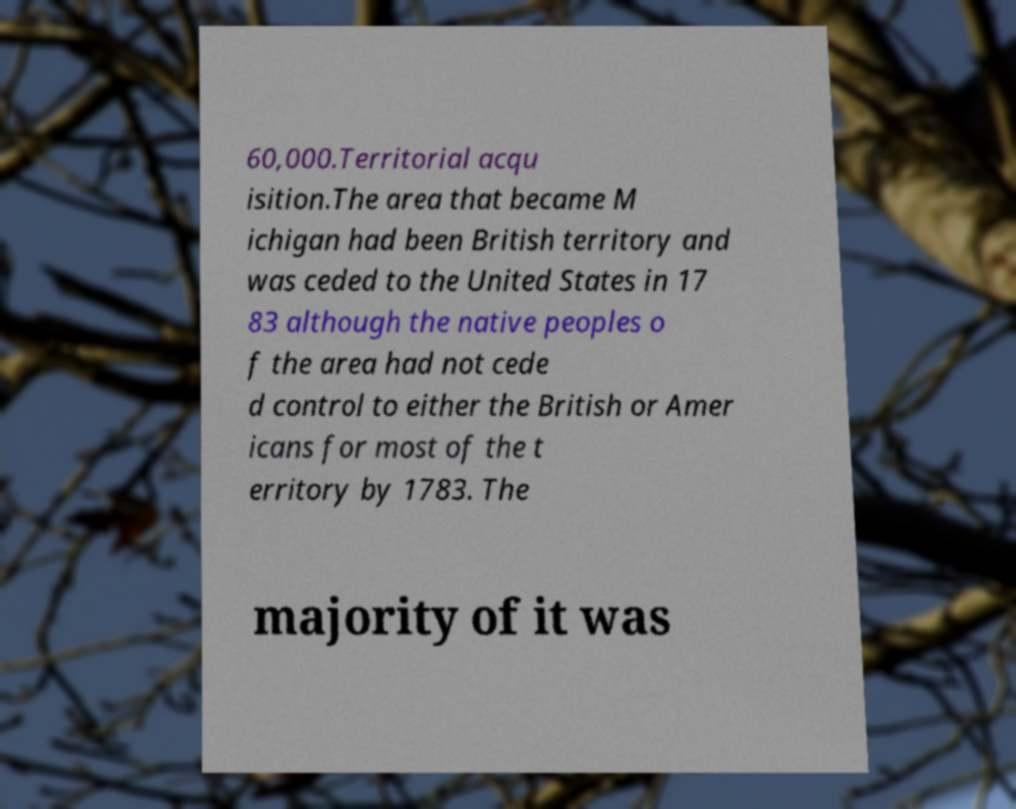Can you read and provide the text displayed in the image?This photo seems to have some interesting text. Can you extract and type it out for me? 60,000.Territorial acqu isition.The area that became M ichigan had been British territory and was ceded to the United States in 17 83 although the native peoples o f the area had not cede d control to either the British or Amer icans for most of the t erritory by 1783. The majority of it was 